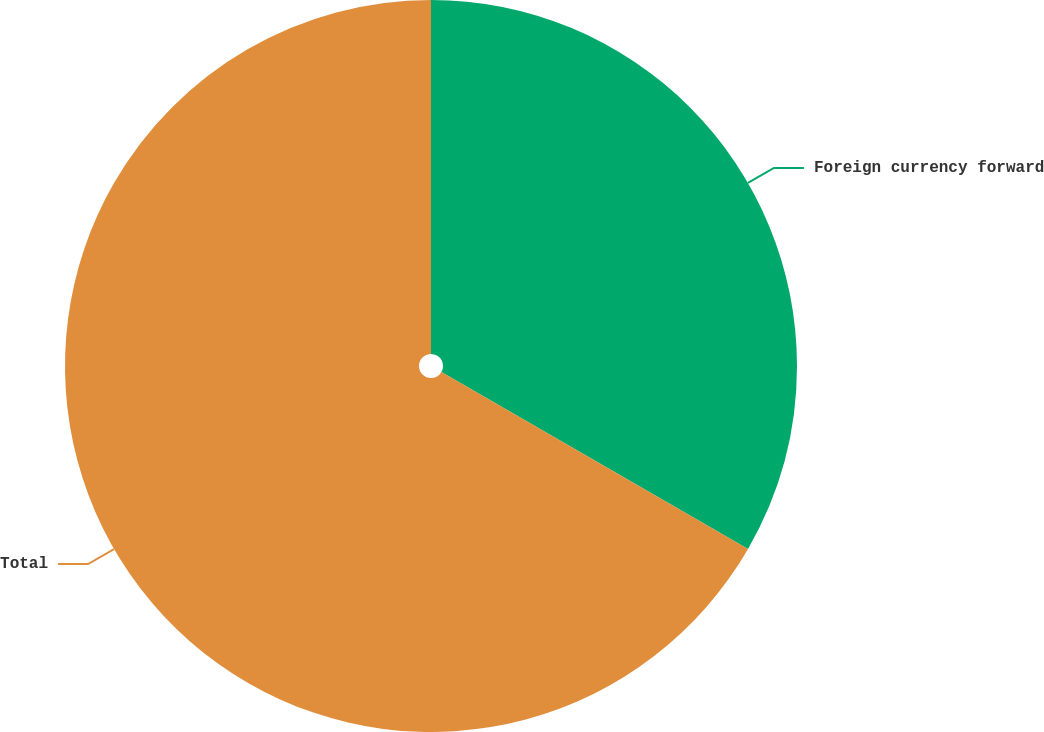Convert chart. <chart><loc_0><loc_0><loc_500><loc_500><pie_chart><fcel>Foreign currency forward<fcel>Total<nl><fcel>33.33%<fcel>66.67%<nl></chart> 